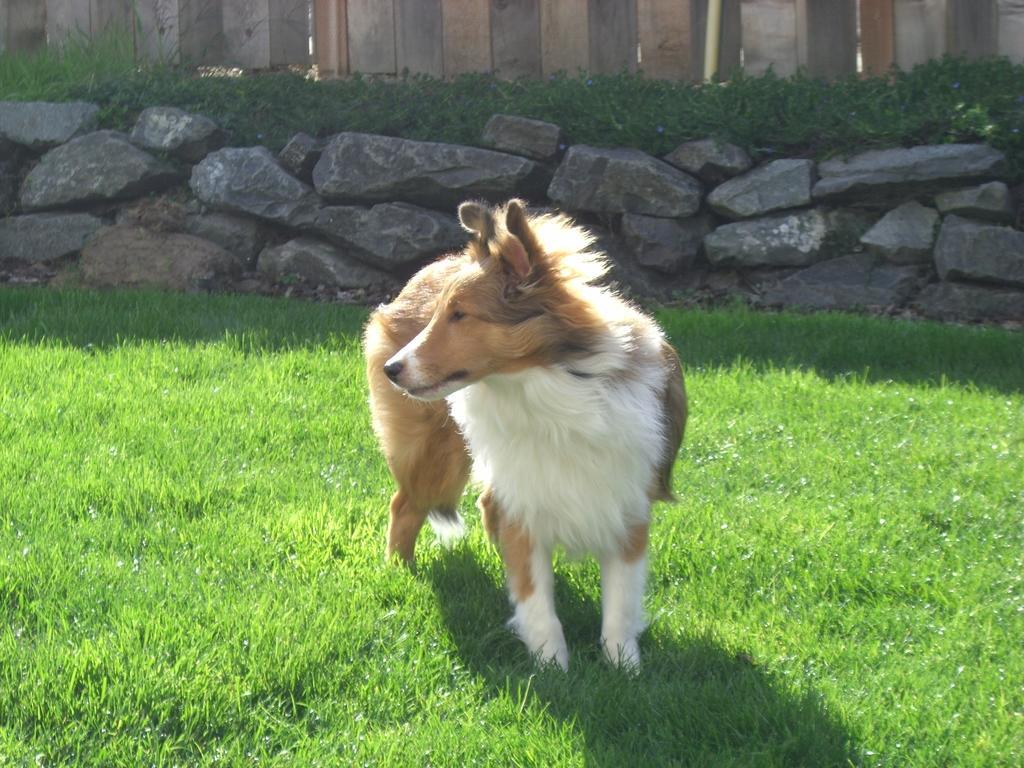Describe this image in one or two sentences. Here I can see a dog in the garden. It is looking at the left side. In the background, I can see some rocks and plants. At the top there is a wall which is made up of wood. 